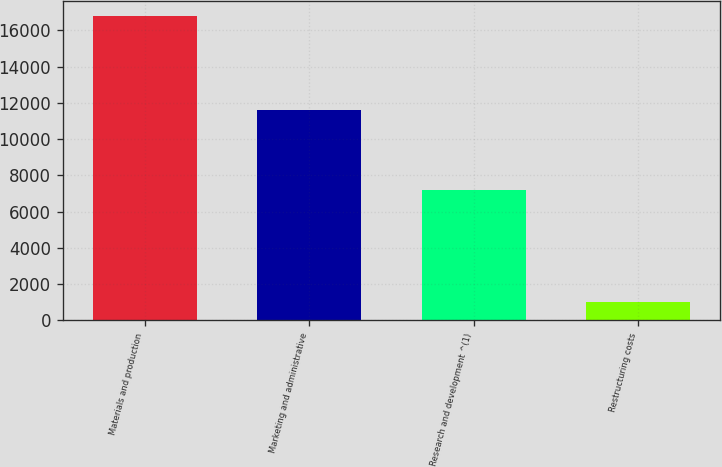Convert chart to OTSL. <chart><loc_0><loc_0><loc_500><loc_500><bar_chart><fcel>Materials and production<fcel>Marketing and administrative<fcel>Research and development ^(1)<fcel>Restructuring costs<nl><fcel>16768<fcel>11606<fcel>7180<fcel>1013<nl></chart> 